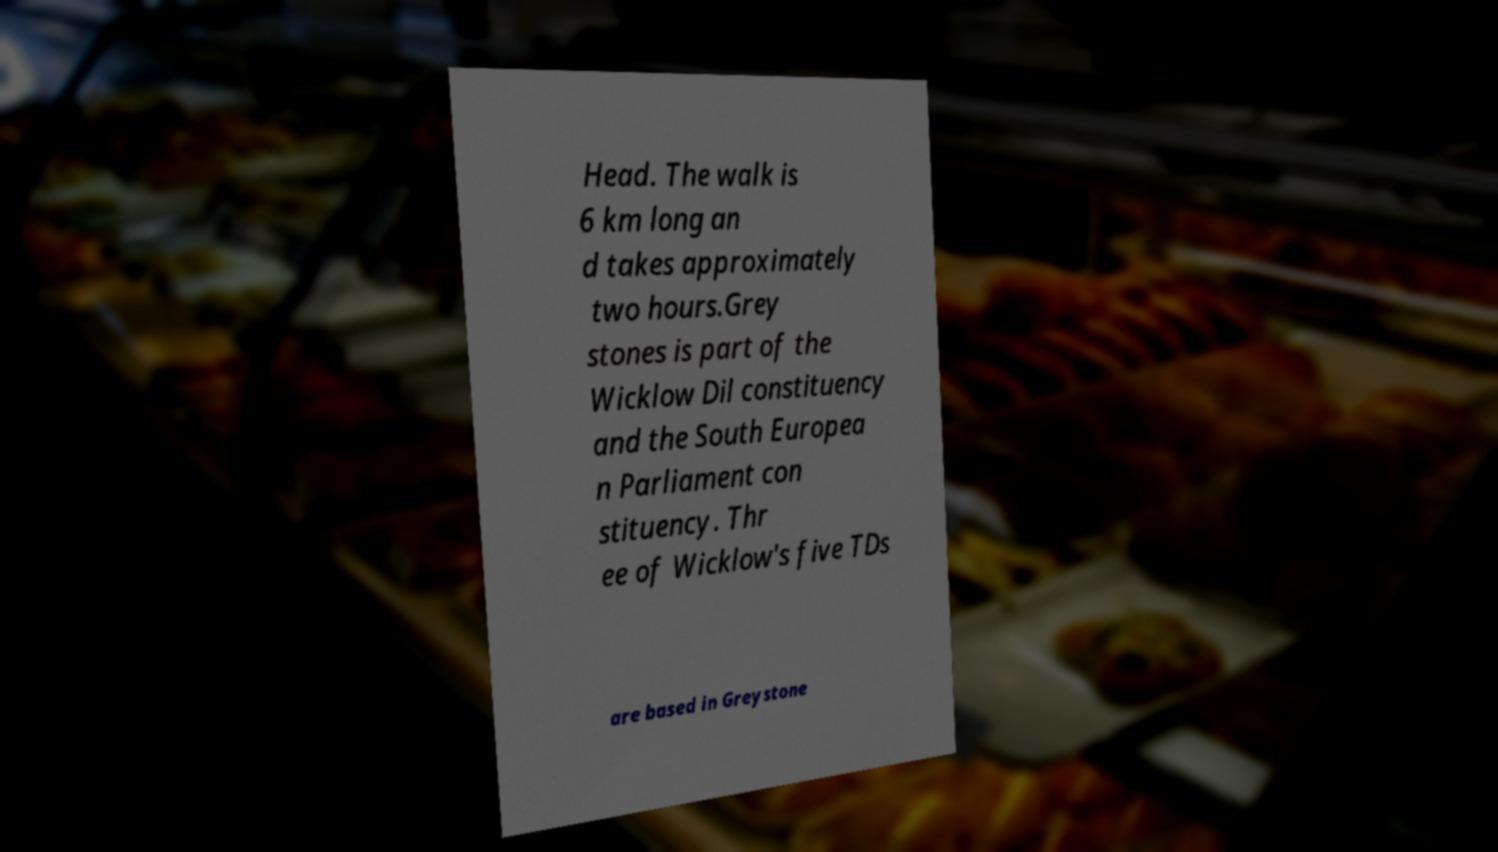Can you read and provide the text displayed in the image?This photo seems to have some interesting text. Can you extract and type it out for me? Head. The walk is 6 km long an d takes approximately two hours.Grey stones is part of the Wicklow Dil constituency and the South Europea n Parliament con stituency. Thr ee of Wicklow's five TDs are based in Greystone 